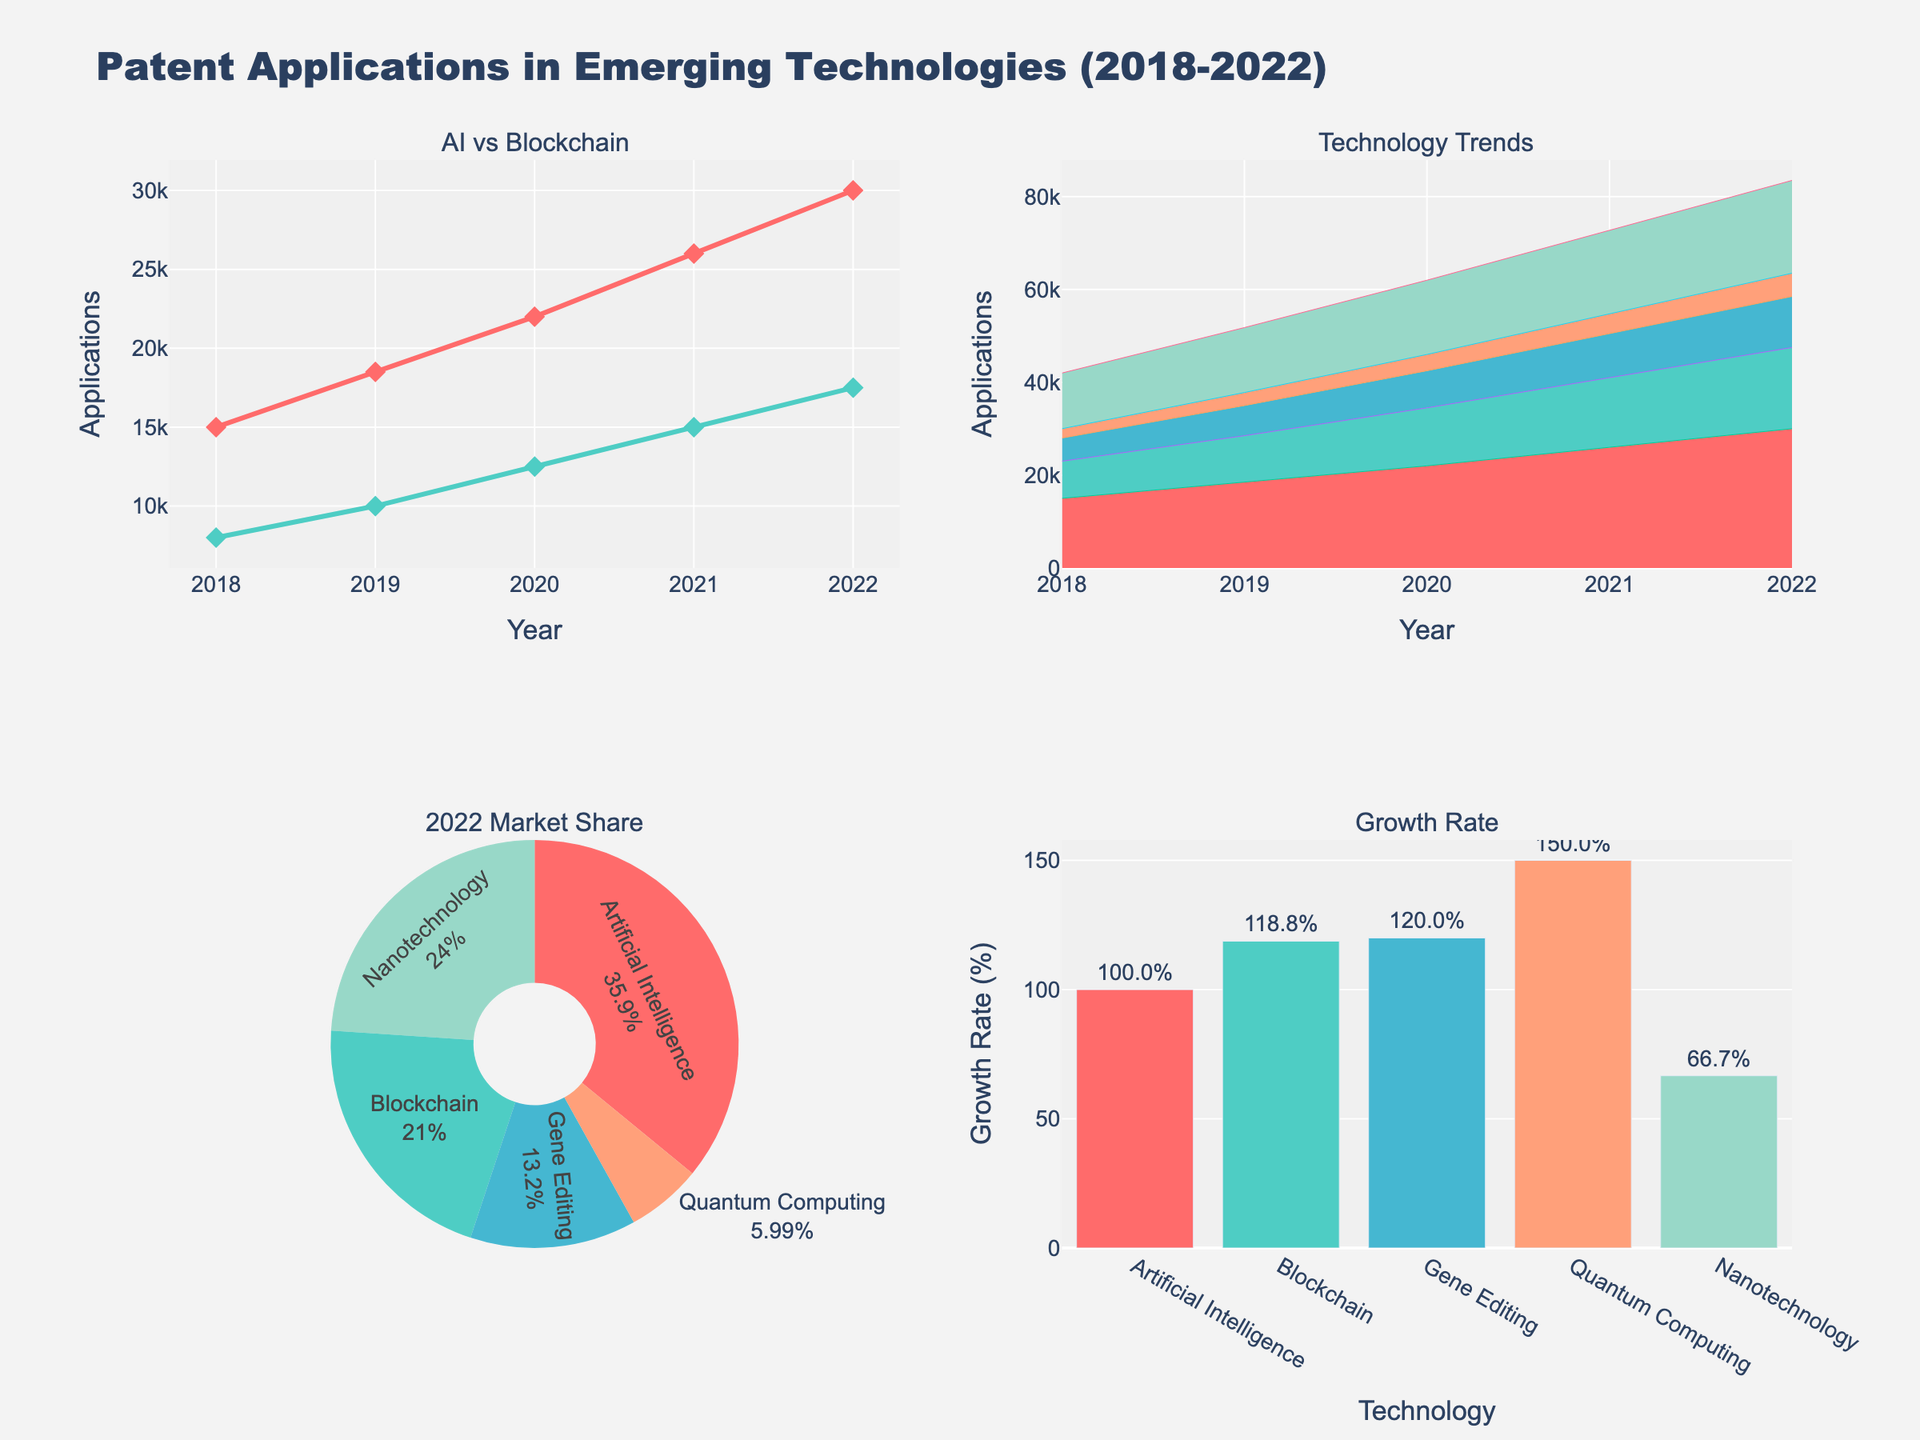What's the title of the figure? The title of the figure is displayed prominently at the top and reads "Age Distribution of Local Event Attendees".
Answer: Age Distribution of Local Event Attendees Which event has the highest number of attendees in the 25-34 age group? By observing the bars corresponding to the 25-34 age group, the "Old Soul Tattoo Anniversary Party" has the highest count with 35 attendees.
Answer: Old Soul Tattoo Anniversary Party How many age groups are represented in the subplots? There are 5 different age groups presented in the subplots, as seen by the different colored bars in each horizontal bar chart.
Answer: 5 What is the total number of attendees aged 35-44 at the Community Farmers Market and Craft Beer Tasting Event? For Community Farmers Market: 25 attendees. Craft Beer Tasting Event: 25 attendees. Adding both, we get 25 + 25 = 50 attendees.
Answer: 50 Which age group has the least representation at the Vintage Car Show? The least represented age group at the Vintage Car Show is the 18-24 age group with only 5 attendees, which is the smallest bar in that subplot.
Answer: 18-24 Is there an event where the 45-54 age group is the largest attendee group? By examining the height of the bars in the 45-54 category, the Vintage Car Show has the largest representation in this age group with 30 attendees, which is the highest value for this group across all events.
Answer: Yes What is the combined number of attendees aged 45-54 and 55+ at the Downtown Arts Festival? Downtown Arts Festival attendees aged 45-54: 20, and aged 55+: 10. Adding both, we get 20 + 10 = 30 attendees.
Answer: 30 Which event has the most balanced distribution of attendees across all age groups? By visually comparing the bar lengths across all subplots, the Community Farmers Market shows a more balanced distribution where no single age group dominates significantly compared to others.
Answer: Community Farmers Market What is the average number of attendees in the 18-24 age group across all events? Summing up all attendees in the 18-24 age group across events: 30 + 15 + 25 + 10 + 20 + 5 = 105. With 6 events, the average is 105 / 6 = 17.5 attendees.
Answer: 17.5 Between the Local Music Jam Night and Craft Beer Tasting Event, which has a higher total number of attendees in the 25-34 and 35-44 age groups combined? Local Music Jam Night: 25-34 (30) + 35-44 (25) = 55. Craft Beer Tasting Event: 25-34 (35) + 35-44 (25) = 60. Craft Beer Tasting Event has a higher total of 60.
Answer: Craft Beer Tasting Event 